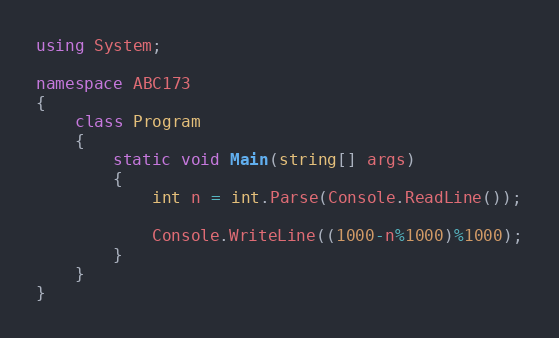Convert code to text. <code><loc_0><loc_0><loc_500><loc_500><_C#_>using System;

namespace ABC173
{
    class Program
    {
        static void Main(string[] args)
        {
            int n = int.Parse(Console.ReadLine());

            Console.WriteLine((1000-n%1000)%1000);
        }
    }
}</code> 